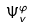<formula> <loc_0><loc_0><loc_500><loc_500>\Psi _ { v } ^ { \varphi }</formula> 